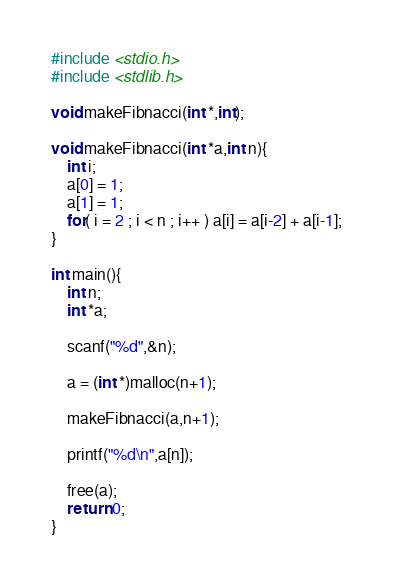Convert code to text. <code><loc_0><loc_0><loc_500><loc_500><_C_>#include <stdio.h>
#include <stdlib.h>

void makeFibnacci(int *,int);

void makeFibnacci(int *a,int n){
	int i;
	a[0] = 1;
	a[1] = 1;
	for( i = 2 ; i < n ; i++ ) a[i] = a[i-2] + a[i-1];
}

int main(){
	int n;
	int *a;

	scanf("%d",&n);

	a = (int *)malloc(n+1);

	makeFibnacci(a,n+1);

	printf("%d\n",a[n]);

	free(a);
	return 0;
}</code> 